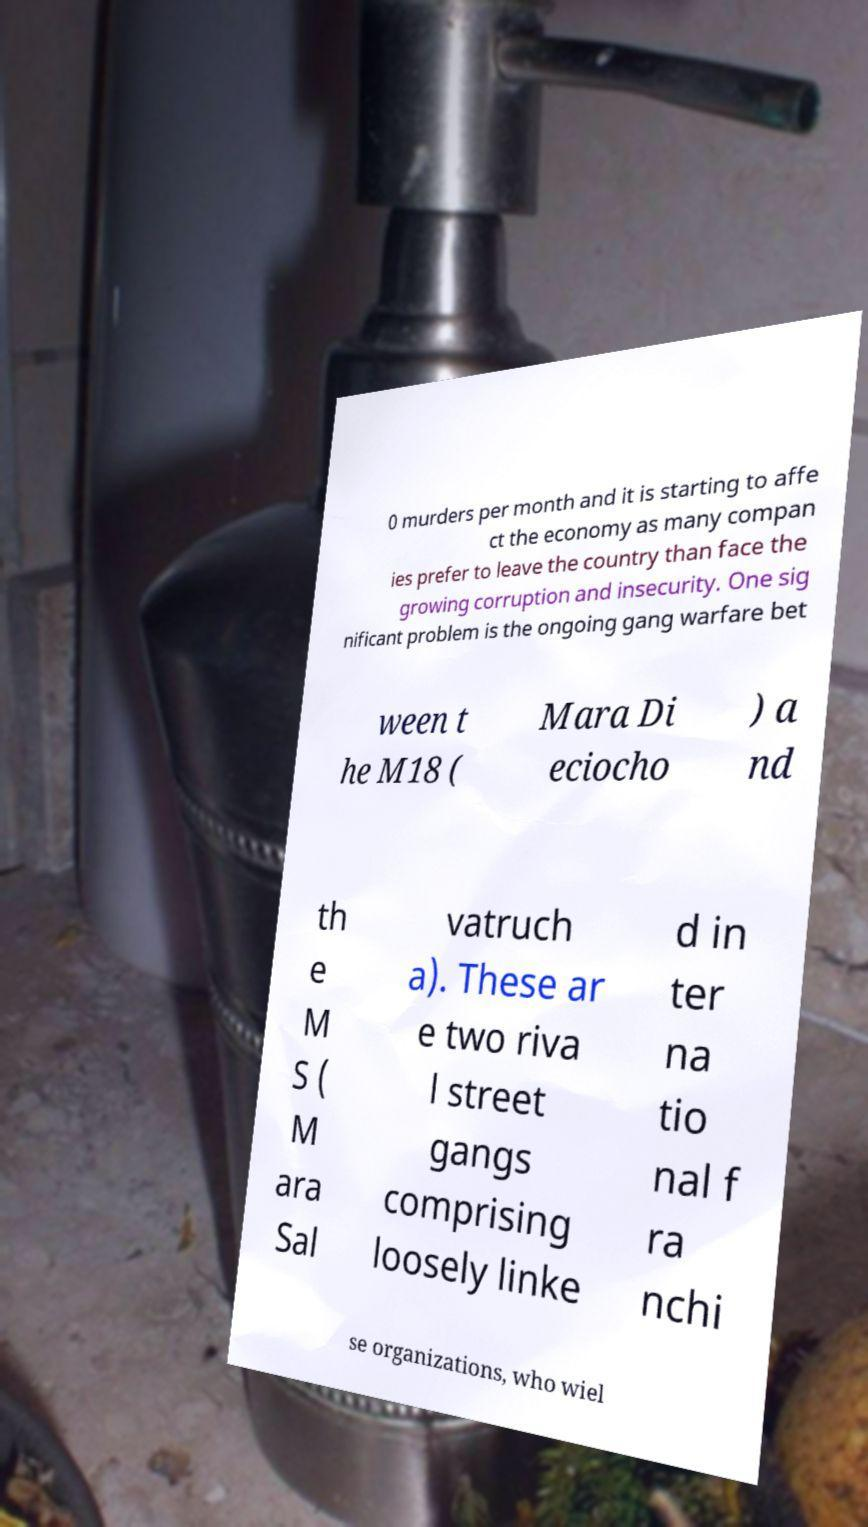Please read and relay the text visible in this image. What does it say? 0 murders per month and it is starting to affe ct the economy as many compan ies prefer to leave the country than face the growing corruption and insecurity. One sig nificant problem is the ongoing gang warfare bet ween t he M18 ( Mara Di eciocho ) a nd th e M S ( M ara Sal vatruch a). These ar e two riva l street gangs comprising loosely linke d in ter na tio nal f ra nchi se organizations, who wiel 